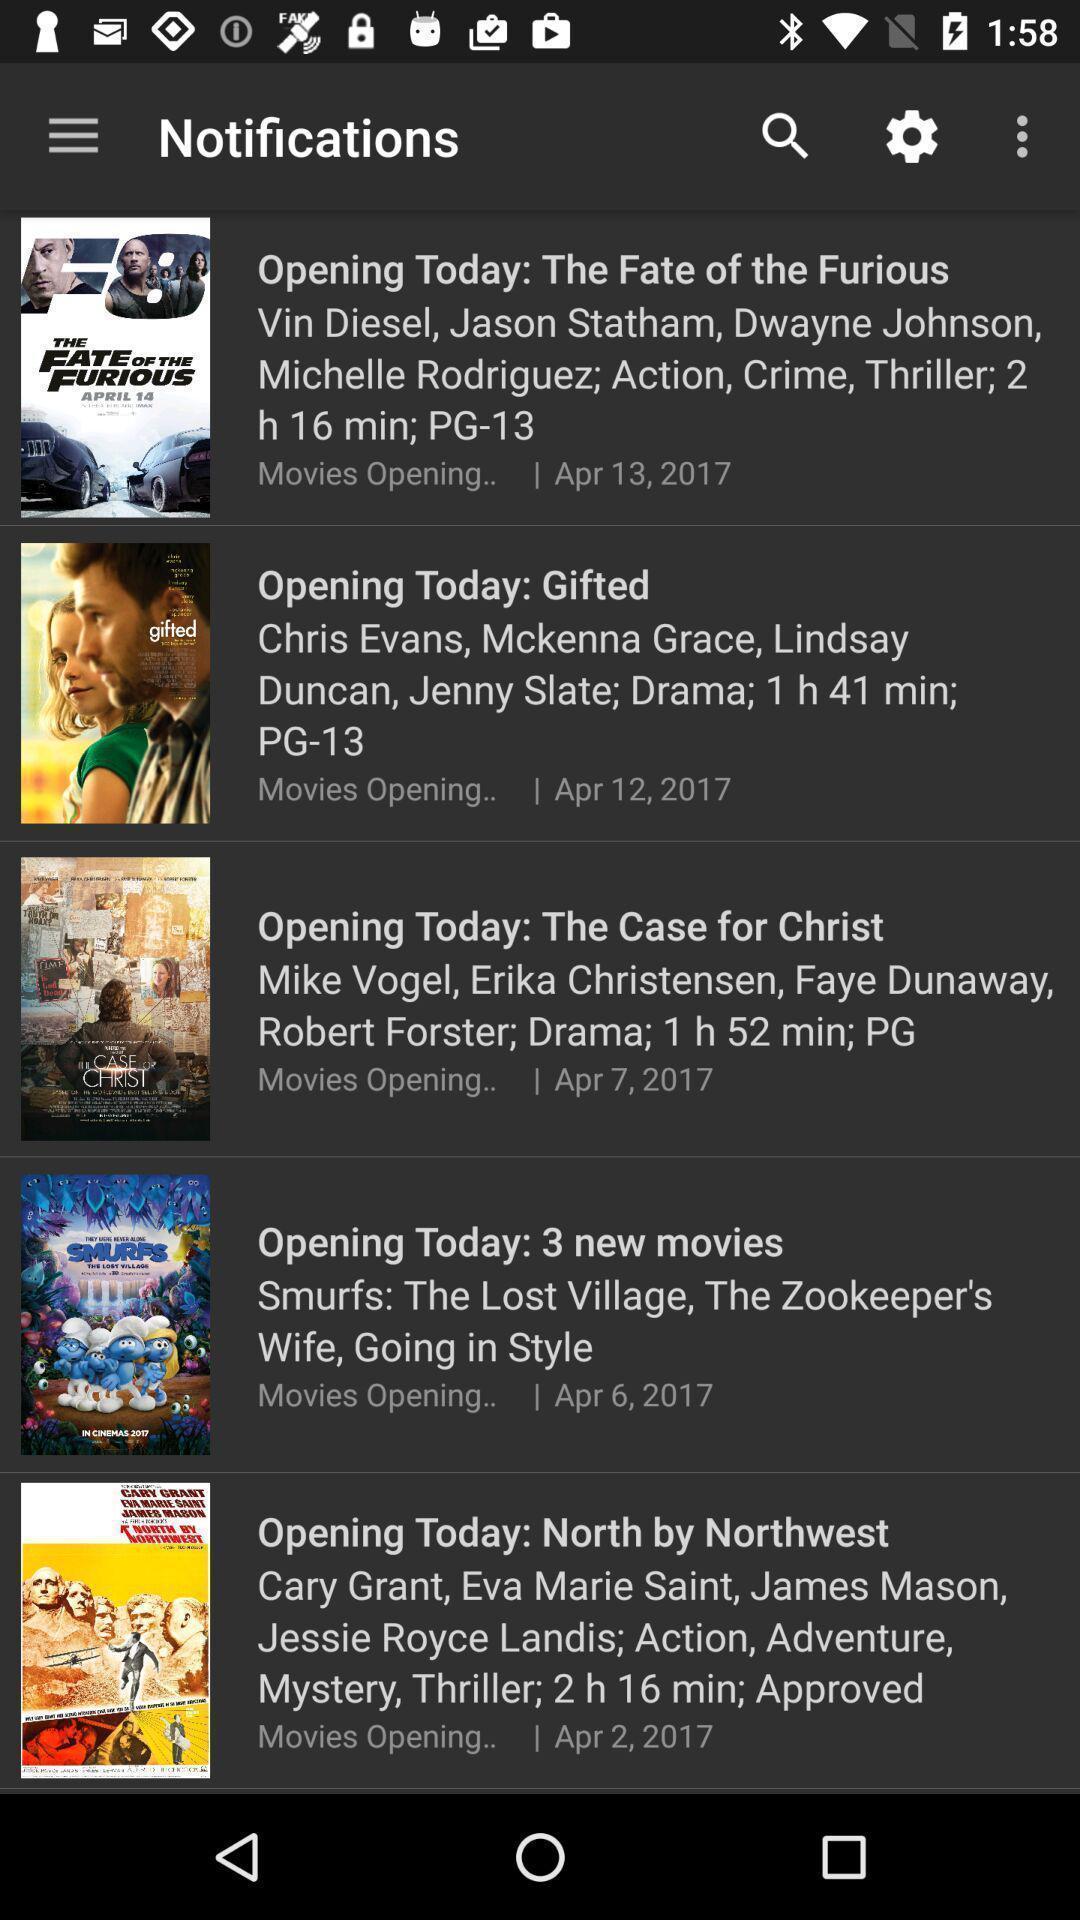Summarize the main components in this picture. Screen shows list of notifications in entertainment app. 